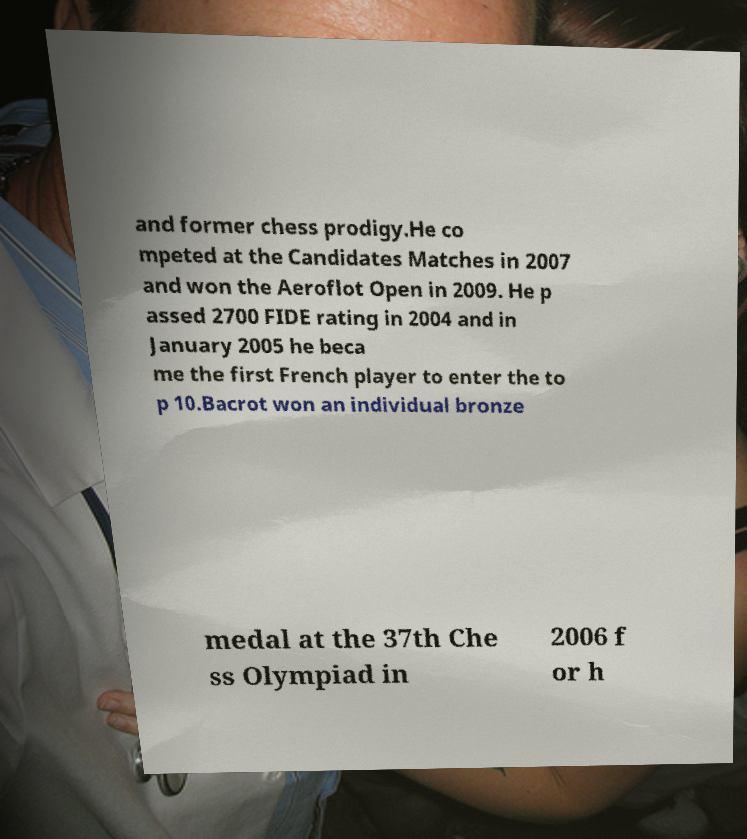There's text embedded in this image that I need extracted. Can you transcribe it verbatim? and former chess prodigy.He co mpeted at the Candidates Matches in 2007 and won the Aeroflot Open in 2009. He p assed 2700 FIDE rating in 2004 and in January 2005 he beca me the first French player to enter the to p 10.Bacrot won an individual bronze medal at the 37th Che ss Olympiad in 2006 f or h 